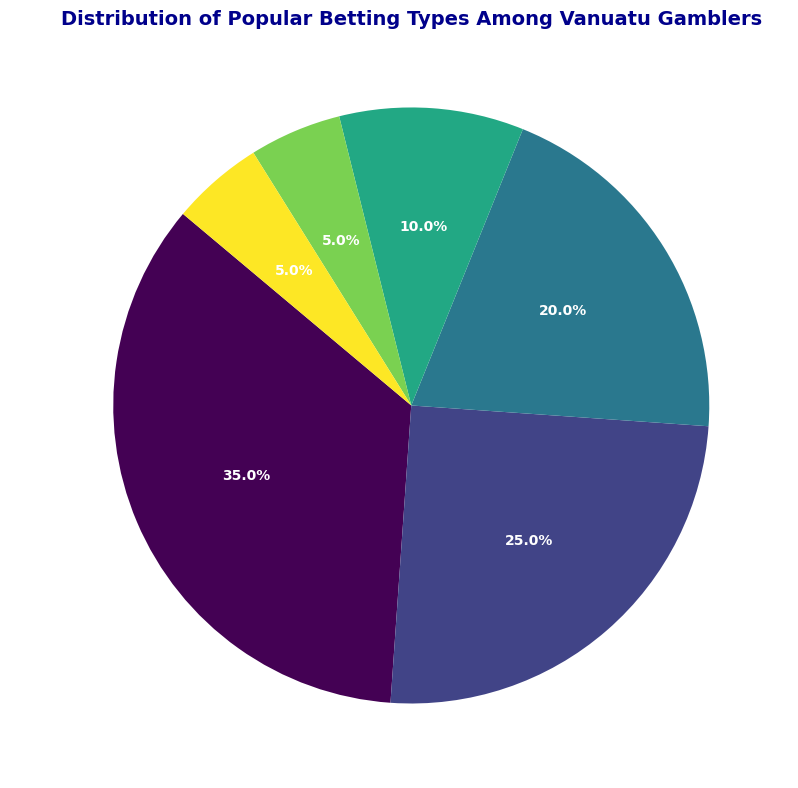What is the most popular betting type among Vanuatu gamblers? The pie chart shows the largest segment labeled as 'Sports Betting', which occupies the largest proportion of the pie.
Answer: Sports Betting Which two betting types together make up more than half of the distribution? The two largest segments in the pie chart are 'Sports Betting' (35%) and 'Horse Racing' (25%). Together, they sum up to 60%, which is more than half of the total distribution.
Answer: Sports Betting and Horse Racing What is the combined percentage of Casino Games and Lottery betting types? 'Casino Games' has 20% and 'Lottery' has 10%. Adding these two percentages: 20% + 10% = 30%.
Answer: 30% How does the percentage of Online Poker compare to that of Casino Games? The pie chart shows 'Online Poker' at 5% and 'Casino Games' at 20%. Comparing these, Online Poker has a smaller percentage than Casino Games.
Answer: Online Poker is smaller Out of all betting types, which two categories have the same percentage? The pie chart indicates 'Online Poker' and 'Other' each have a 5% share.
Answer: Online Poker and Other What percentage of the distribution does sports-related betting (combining Sports Betting and Horse Racing) account for? 'Sports Betting' has 35% and 'Horse Racing' has 25%. Combining these: 35% + 25% = 60%.
Answer: 60% Which betting type has exactly double the percentage of Online Poker? 'Online Poker' is 5%. The percentage which is exactly double of this is 10%. Referring to the chart, 'Lottery' represents 10%.
Answer: Lottery If you combine the percentages of the least popular betting types (those with 5%), what is the total percentage? The least popular types are 'Online Poker' and 'Other', each with 5%. Adding these: 5% + 5% = 10%.
Answer: 10% How many betting types have a percentage higher than 20%? The chart shows that 'Sports Betting' (35%) and 'Horse Racing' (25%) are above 20%. That makes two categories.
Answer: 2 